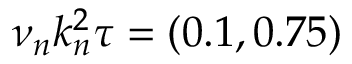Convert formula to latex. <formula><loc_0><loc_0><loc_500><loc_500>\nu _ { n } k _ { n } ^ { 2 } \tau = ( 0 . 1 , 0 . 7 5 )</formula> 